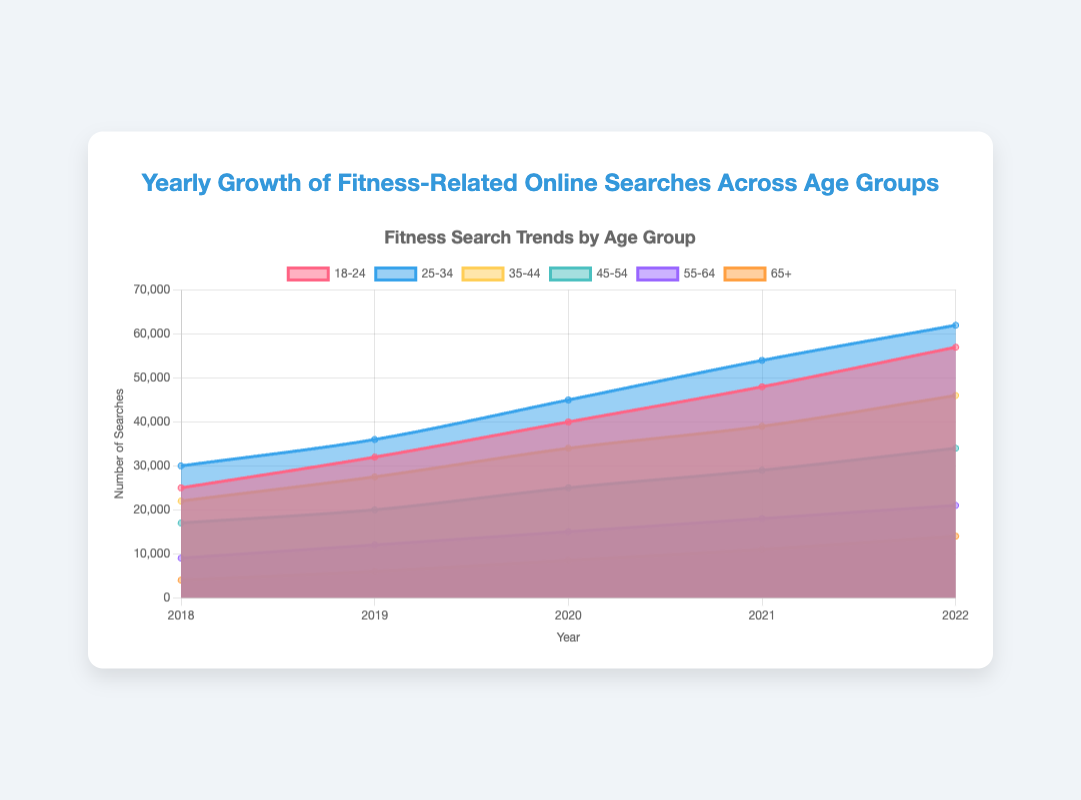What is the total number of searches in 2022? To find the total number of searches in 2022, sum all the values for each age group in that year: 57000 + 62000 + 46000 + 34000 + 21000 + 14000 = 234000
Answer: 234000 Which age group had the highest number of searches in 2021? To determine the age group with the highest number of searches in 2021, compare the values for all age groups in that year: 48000 (18-24), 54000 (25-34), 39000 (35-44), 29000 (45-54), 18000 (55-64), 11000 (65+). The highest value is 54000, which corresponds to the 25-34 age group
Answer: 25-34 How much did the searches for the 65+ group increase from 2018 to 2022? To find the increase, subtract the number of searches in 2018 from the number in 2022 for the 65+ group: 14000 (2022) - 4000 (2018) = 10000
Answer: 10000 Which age group showed the smallest growth in searches from 2018 to 2022? To determine the smallest growth, calculate the increase for each group and find the smallest value: 32000 (18-24), 32000 (25-34), 24000 (35-44), 17000 (45-54), 12000 (55-64), 10000 (65+). The group with the smallest growth is the 65+ group with an increase of 10000
Answer: 65+ What is the average number of searches for the 25-34 age group across all years? Add the number of searches for each year and divide by the number of years: (30000 + 36000 + 45000 + 54000 + 62000) / 5 = 227000 / 5 = 45400
Answer: 45400 Between which two consecutive years did the 18-24 age group see the largest increase in searches? Calculate the increase between each pair of consecutive years and identify the largest: 32000-25000=7000 (2018-2019), 40000-32000=8000 (2019-2020), 48000-40000=8000 (2020-2021), 57000-48000=9000 (2021-2022). The largest increase is between 2021 and 2022
Answer: 2021 and 2022 In which year did the 55-64 age group have 15000 searches? Identify the number of searches that match 15000 in the 55-64 group: 2018-9000, 2019-12000, 2020-15000, 2021-18000, 2022-21000. The matching year is 2020
Answer: 2020 How much did the searches for the 35-44 age group increase from 2019 to 2020? Subtract the number of searches in 2019 from the number in 2020 for the 35-44 group: 34000 (2020) - 27500 (2019) = 6500
Answer: 6500 Which age group saw the biggest year-over-year increase in searches from 2018 to 2019? Calculate the increase for each group from 2018 to 2019 and find the largest value: 32000-25000=7000 (18-24), 36000-30000=6000 (25-34), 27500-22000=5500 (35-44), 20000-17000=3000 (45-54), 12000-9000=3000 (55-64), 6000-4000=2000 (65+). The largest increase is for the 18-24 group with 7000
Answer: 18-24 